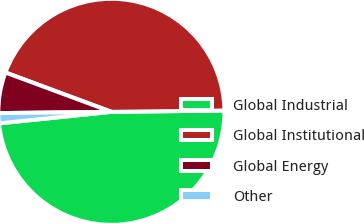Convert chart to OTSL. <chart><loc_0><loc_0><loc_500><loc_500><pie_chart><fcel>Global Industrial<fcel>Global Institutional<fcel>Global Energy<fcel>Other<nl><fcel>48.55%<fcel>44.16%<fcel>5.84%<fcel>1.45%<nl></chart> 